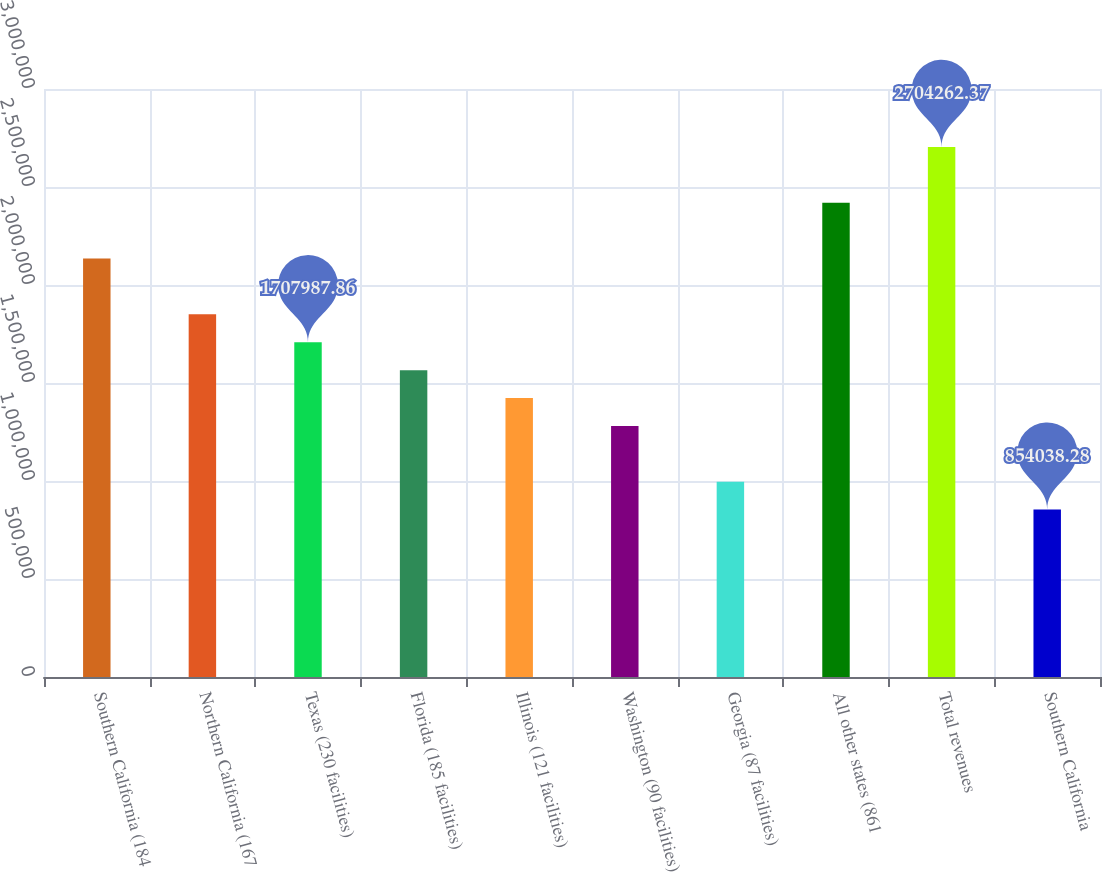<chart> <loc_0><loc_0><loc_500><loc_500><bar_chart><fcel>Southern California (184<fcel>Northern California (167<fcel>Texas (230 facilities)<fcel>Florida (185 facilities)<fcel>Illinois (121 facilities)<fcel>Washington (90 facilities)<fcel>Georgia (87 facilities)<fcel>All other states (861<fcel>Total revenues<fcel>Southern California<nl><fcel>2.13496e+06<fcel>1.85031e+06<fcel>1.70799e+06<fcel>1.56566e+06<fcel>1.42334e+06<fcel>1.28101e+06<fcel>996363<fcel>2.41961e+06<fcel>2.70426e+06<fcel>854038<nl></chart> 